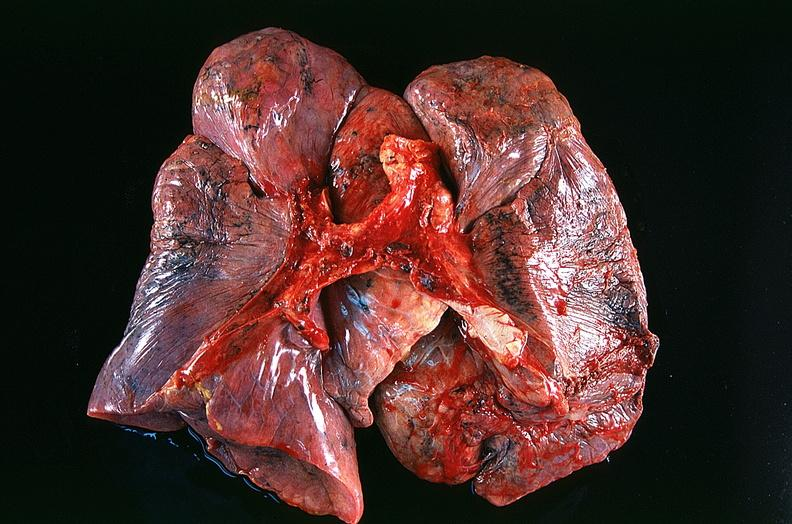where is this?
Answer the question using a single word or phrase. Lung 